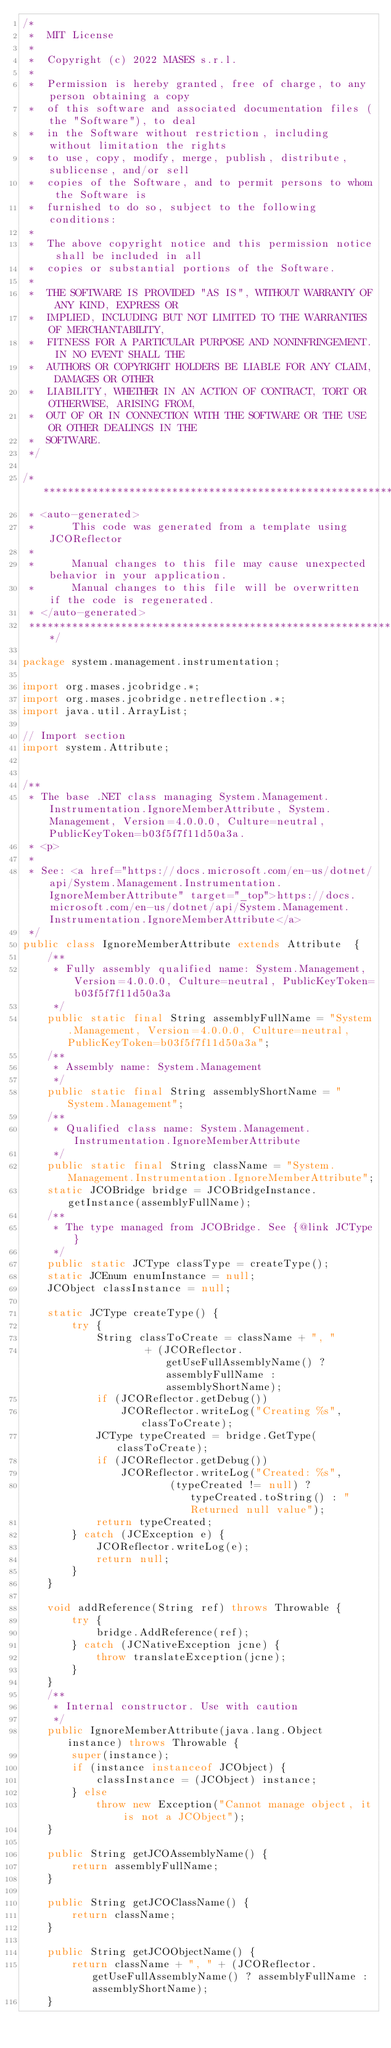<code> <loc_0><loc_0><loc_500><loc_500><_Java_>/*
 *  MIT License
 *
 *  Copyright (c) 2022 MASES s.r.l.
 *
 *  Permission is hereby granted, free of charge, to any person obtaining a copy
 *  of this software and associated documentation files (the "Software"), to deal
 *  in the Software without restriction, including without limitation the rights
 *  to use, copy, modify, merge, publish, distribute, sublicense, and/or sell
 *  copies of the Software, and to permit persons to whom the Software is
 *  furnished to do so, subject to the following conditions:
 *
 *  The above copyright notice and this permission notice shall be included in all
 *  copies or substantial portions of the Software.
 *
 *  THE SOFTWARE IS PROVIDED "AS IS", WITHOUT WARRANTY OF ANY KIND, EXPRESS OR
 *  IMPLIED, INCLUDING BUT NOT LIMITED TO THE WARRANTIES OF MERCHANTABILITY,
 *  FITNESS FOR A PARTICULAR PURPOSE AND NONINFRINGEMENT. IN NO EVENT SHALL THE
 *  AUTHORS OR COPYRIGHT HOLDERS BE LIABLE FOR ANY CLAIM, DAMAGES OR OTHER
 *  LIABILITY, WHETHER IN AN ACTION OF CONTRACT, TORT OR OTHERWISE, ARISING FROM,
 *  OUT OF OR IN CONNECTION WITH THE SOFTWARE OR THE USE OR OTHER DEALINGS IN THE
 *  SOFTWARE.
 */

/**************************************************************************************
 * <auto-generated>
 *      This code was generated from a template using JCOReflector
 * 
 *      Manual changes to this file may cause unexpected behavior in your application.
 *      Manual changes to this file will be overwritten if the code is regenerated.
 * </auto-generated>
 *************************************************************************************/

package system.management.instrumentation;

import org.mases.jcobridge.*;
import org.mases.jcobridge.netreflection.*;
import java.util.ArrayList;

// Import section
import system.Attribute;


/**
 * The base .NET class managing System.Management.Instrumentation.IgnoreMemberAttribute, System.Management, Version=4.0.0.0, Culture=neutral, PublicKeyToken=b03f5f7f11d50a3a.
 * <p>
 * 
 * See: <a href="https://docs.microsoft.com/en-us/dotnet/api/System.Management.Instrumentation.IgnoreMemberAttribute" target="_top">https://docs.microsoft.com/en-us/dotnet/api/System.Management.Instrumentation.IgnoreMemberAttribute</a>
 */
public class IgnoreMemberAttribute extends Attribute  {
    /**
     * Fully assembly qualified name: System.Management, Version=4.0.0.0, Culture=neutral, PublicKeyToken=b03f5f7f11d50a3a
     */
    public static final String assemblyFullName = "System.Management, Version=4.0.0.0, Culture=neutral, PublicKeyToken=b03f5f7f11d50a3a";
    /**
     * Assembly name: System.Management
     */
    public static final String assemblyShortName = "System.Management";
    /**
     * Qualified class name: System.Management.Instrumentation.IgnoreMemberAttribute
     */
    public static final String className = "System.Management.Instrumentation.IgnoreMemberAttribute";
    static JCOBridge bridge = JCOBridgeInstance.getInstance(assemblyFullName);
    /**
     * The type managed from JCOBridge. See {@link JCType}
     */
    public static JCType classType = createType();
    static JCEnum enumInstance = null;
    JCObject classInstance = null;

    static JCType createType() {
        try {
            String classToCreate = className + ", "
                    + (JCOReflector.getUseFullAssemblyName() ? assemblyFullName : assemblyShortName);
            if (JCOReflector.getDebug())
                JCOReflector.writeLog("Creating %s", classToCreate);
            JCType typeCreated = bridge.GetType(classToCreate);
            if (JCOReflector.getDebug())
                JCOReflector.writeLog("Created: %s",
                        (typeCreated != null) ? typeCreated.toString() : "Returned null value");
            return typeCreated;
        } catch (JCException e) {
            JCOReflector.writeLog(e);
            return null;
        }
    }

    void addReference(String ref) throws Throwable {
        try {
            bridge.AddReference(ref);
        } catch (JCNativeException jcne) {
            throw translateException(jcne);
        }
    }
    /**
     * Internal constructor. Use with caution 
     */
    public IgnoreMemberAttribute(java.lang.Object instance) throws Throwable {
        super(instance);
        if (instance instanceof JCObject) {
            classInstance = (JCObject) instance;
        } else
            throw new Exception("Cannot manage object, it is not a JCObject");
    }

    public String getJCOAssemblyName() {
        return assemblyFullName;
    }

    public String getJCOClassName() {
        return className;
    }

    public String getJCOObjectName() {
        return className + ", " + (JCOReflector.getUseFullAssemblyName() ? assemblyFullName : assemblyShortName);
    }
</code> 